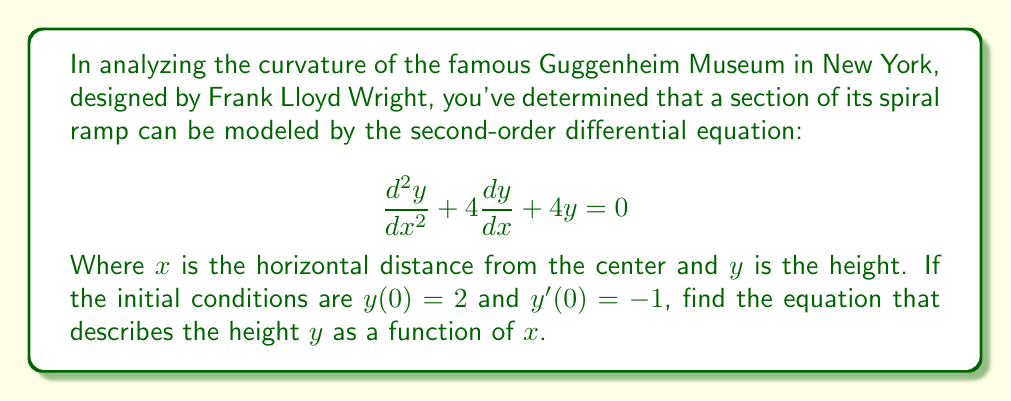Show me your answer to this math problem. To solve this problem, we'll follow these steps:

1) First, we recognize this as a second-order linear homogeneous differential equation with constant coefficients. The characteristic equation is:

   $$r^2 + 4r + 4 = 0$$

2) Solving this quadratic equation:
   $$(r + 2)^2 = 0$$
   $$r = -2$$ (double root)

3) When we have a double root, the general solution takes the form:

   $$y = (c_1 + c_2x)e^{-2x}$$

4) Now we use the initial conditions to find $c_1$ and $c_2$:

   For $y(0) = 2$:
   $$2 = c_1 + 0 \cdot c_2$$
   $$c_1 = 2$$

   For $y'(0) = -1$:
   $$y' = (-2c_1 - 2c_2x + c_2)e^{-2x}$$
   $$-1 = -2(2) + c_2$$
   $$c_2 = 3$$

5) Substituting these values back into our general solution:

   $$y = (2 + 3x)e^{-2x}$$

This equation describes the height $y$ as a function of the horizontal distance $x$ from the center of the Guggenheim's spiral ramp.
Answer: $$y = (2 + 3x)e^{-2x}$$ 